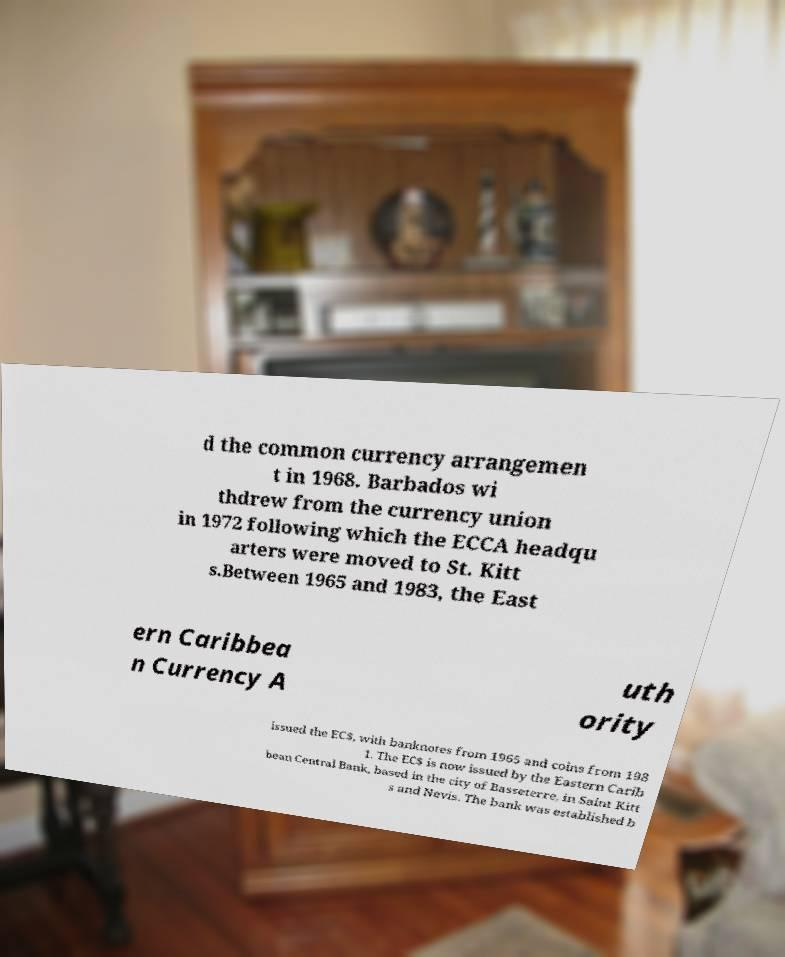I need the written content from this picture converted into text. Can you do that? d the common currency arrangemen t in 1968. Barbados wi thdrew from the currency union in 1972 following which the ECCA headqu arters were moved to St. Kitt s.Between 1965 and 1983, the East ern Caribbea n Currency A uth ority issued the EC$, with banknotes from 1965 and coins from 198 1. The EC$ is now issued by the Eastern Carib bean Central Bank, based in the city of Basseterre, in Saint Kitt s and Nevis. The bank was established b 